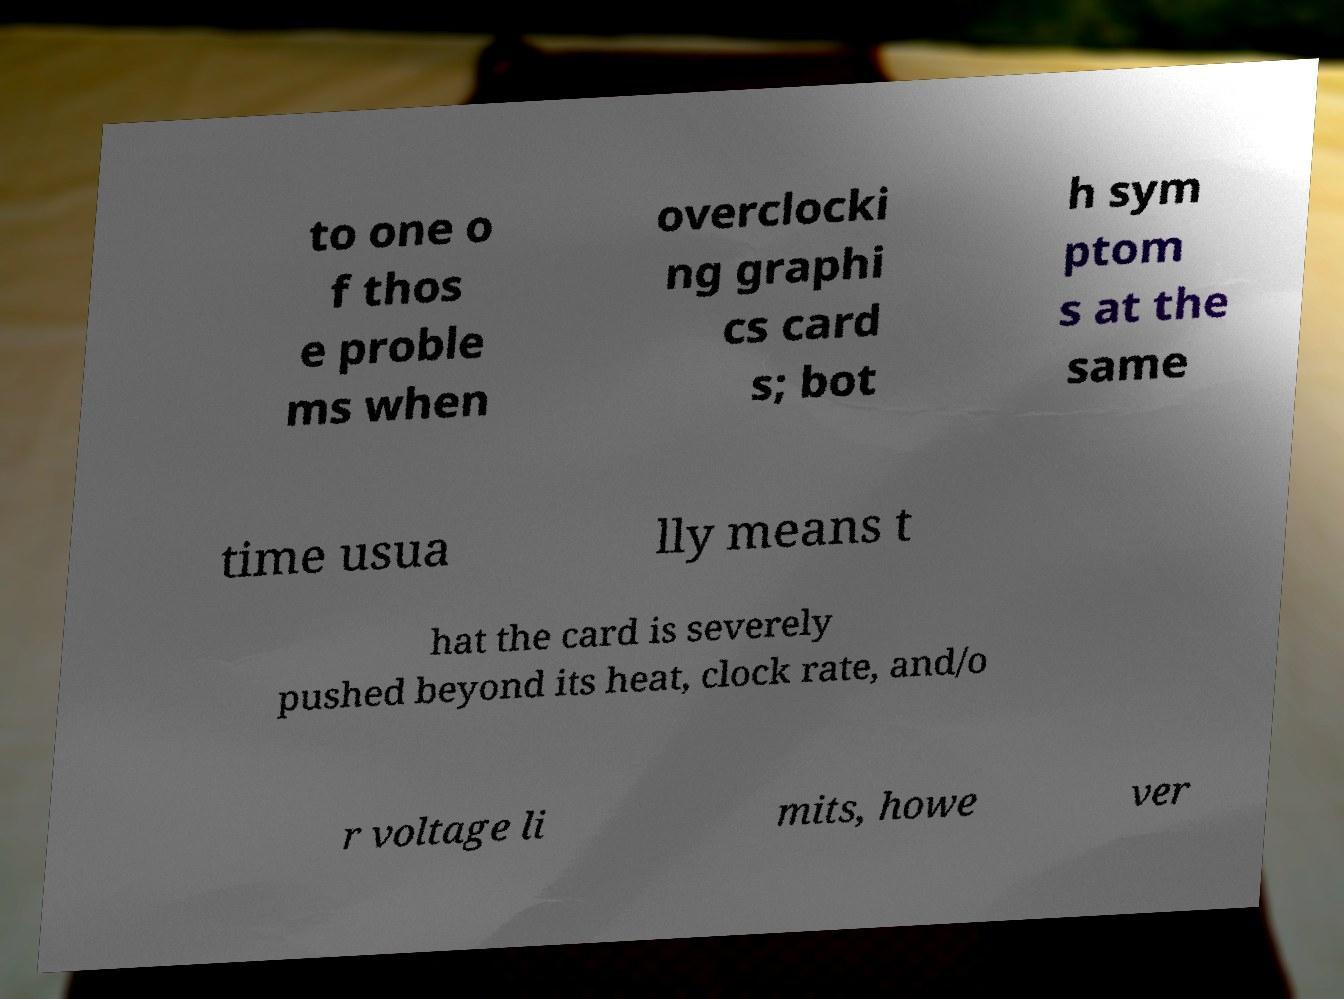Could you assist in decoding the text presented in this image and type it out clearly? to one o f thos e proble ms when overclocki ng graphi cs card s; bot h sym ptom s at the same time usua lly means t hat the card is severely pushed beyond its heat, clock rate, and/o r voltage li mits, howe ver 